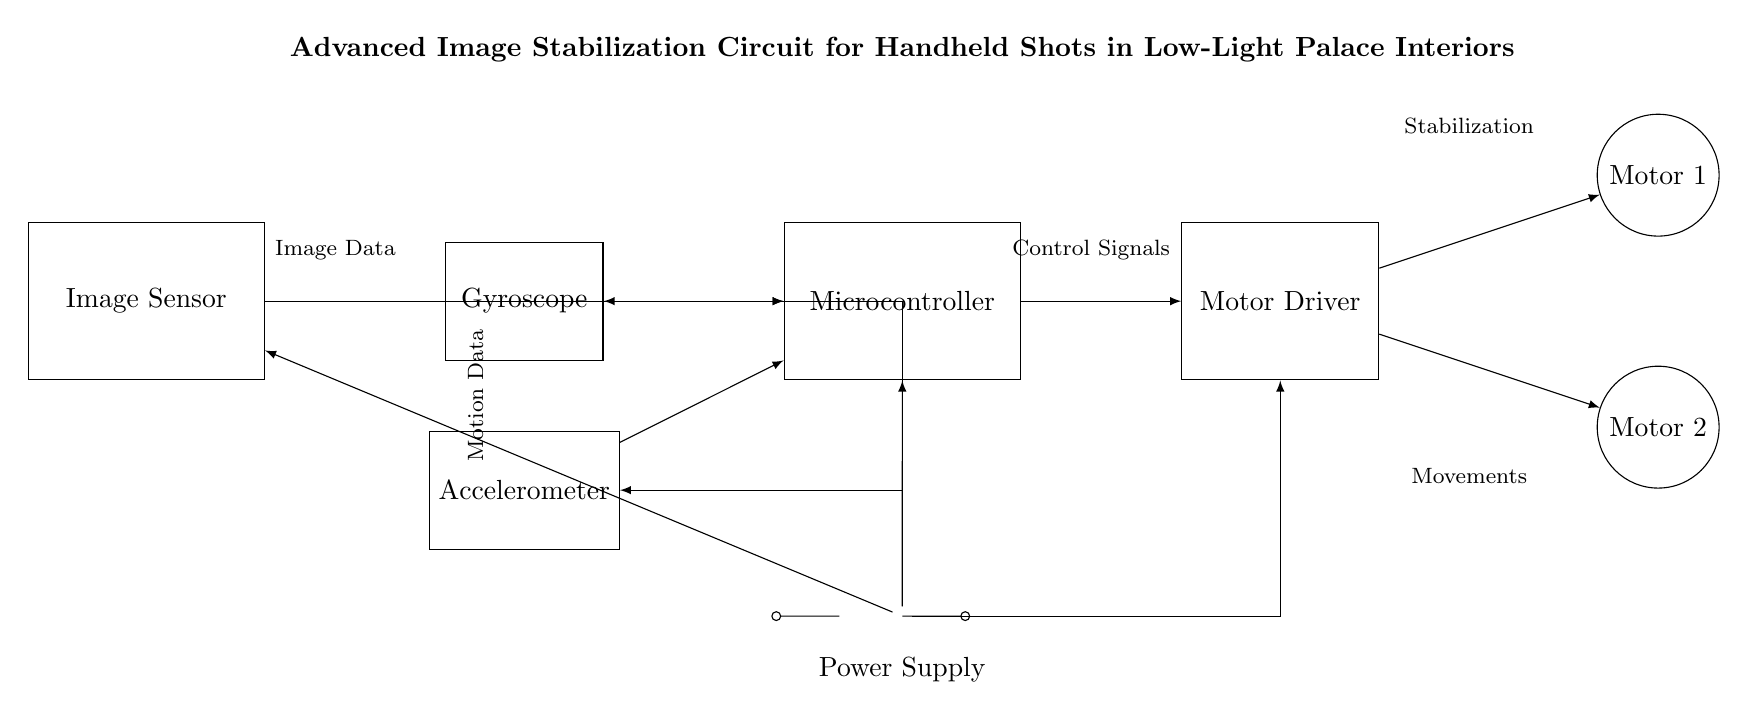What is the function of the gyroscope in this circuit? The gyroscope measures angular motion and provides motion data to the microcontroller for stabilization purposes.
Answer: Angular motion What components provide power to the circuit? The circuit is powered by a battery, which connects to various components including the image sensor, gyroscope, accelerometer, microcontroller, and motor driver.
Answer: Battery How many motors are present in the circuit? Two motors, labeled Motor 1 and Motor 2, are shown in the circuit diagram for lens stabilization.
Answer: Two Which component receives data from the image sensor? The microcontroller receives image data from the image sensor to process and control stabilization.
Answer: Microcontroller What type of data does the accelerometer provide? The accelerometer provides motion data to the microcontroller to assist in stabilizing images by detecting linear motion.
Answer: Motion data Which component controls the motors in this circuit? The motor driver controls the motors based on the signals processed by the microcontroller, influencing stabilization movements.
Answer: Motor driver How does the power supply connect to the gyroscope? The power supply connects to the gyroscope via a direct line, ensuring it receives the necessary power for operation.
Answer: Direct connection 